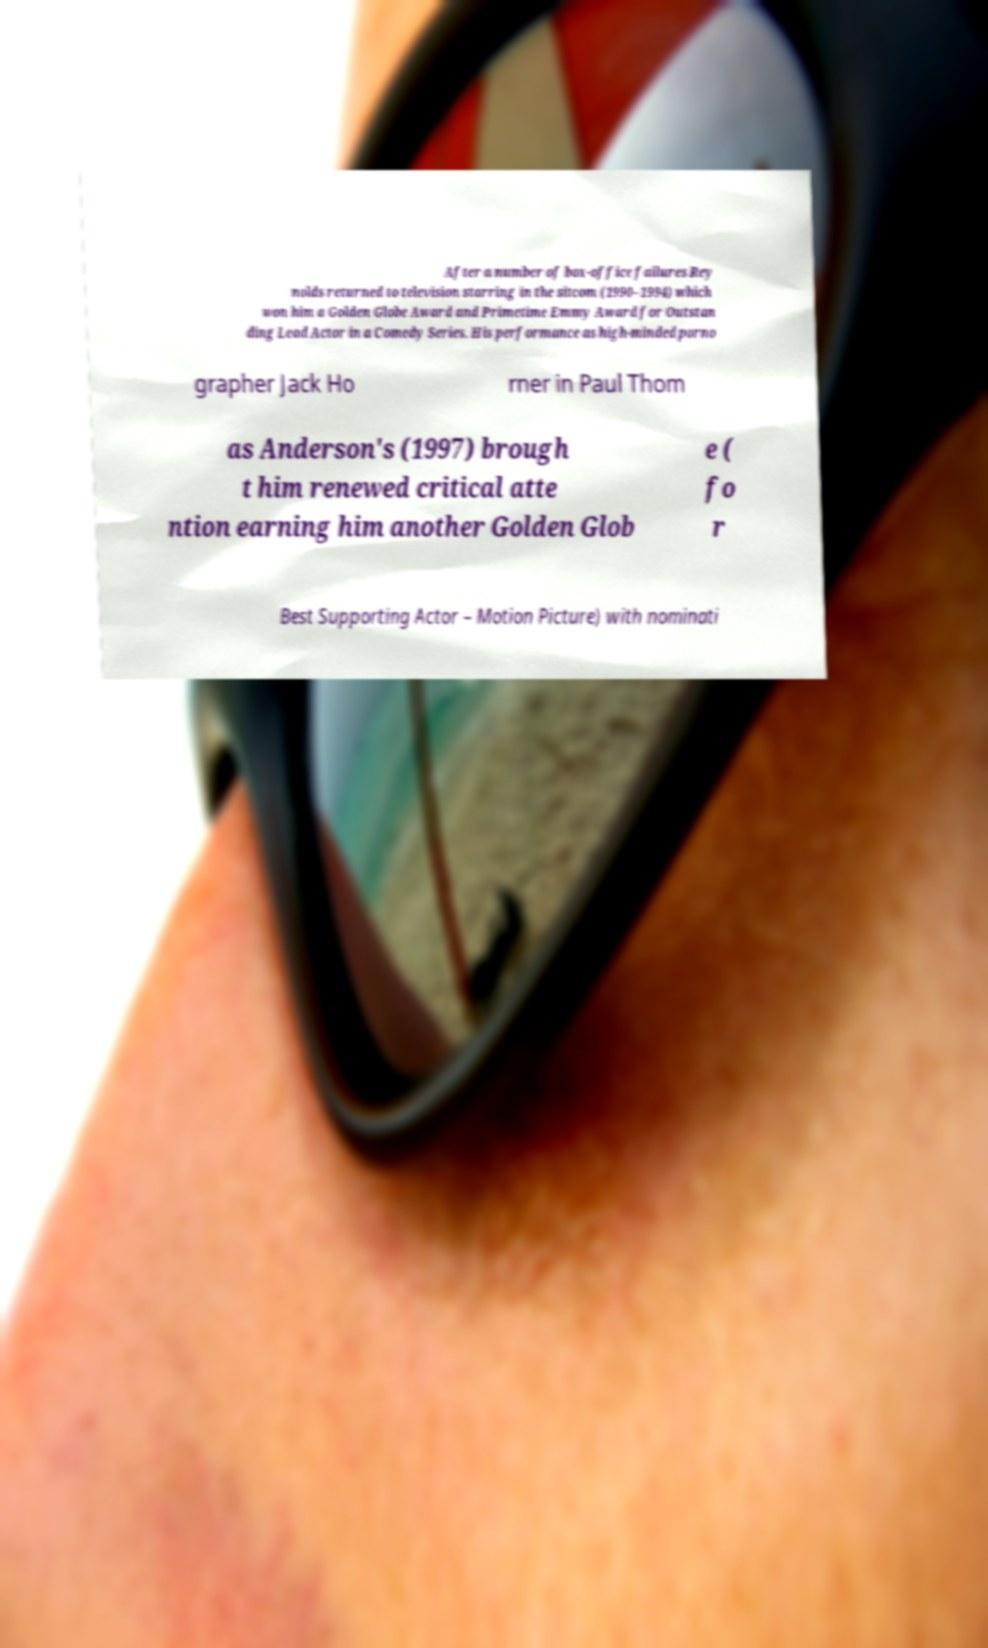Please identify and transcribe the text found in this image. After a number of box-office failures Rey nolds returned to television starring in the sitcom (1990–1994) which won him a Golden Globe Award and Primetime Emmy Award for Outstan ding Lead Actor in a Comedy Series. His performance as high-minded porno grapher Jack Ho rner in Paul Thom as Anderson's (1997) brough t him renewed critical atte ntion earning him another Golden Glob e ( fo r Best Supporting Actor – Motion Picture) with nominati 